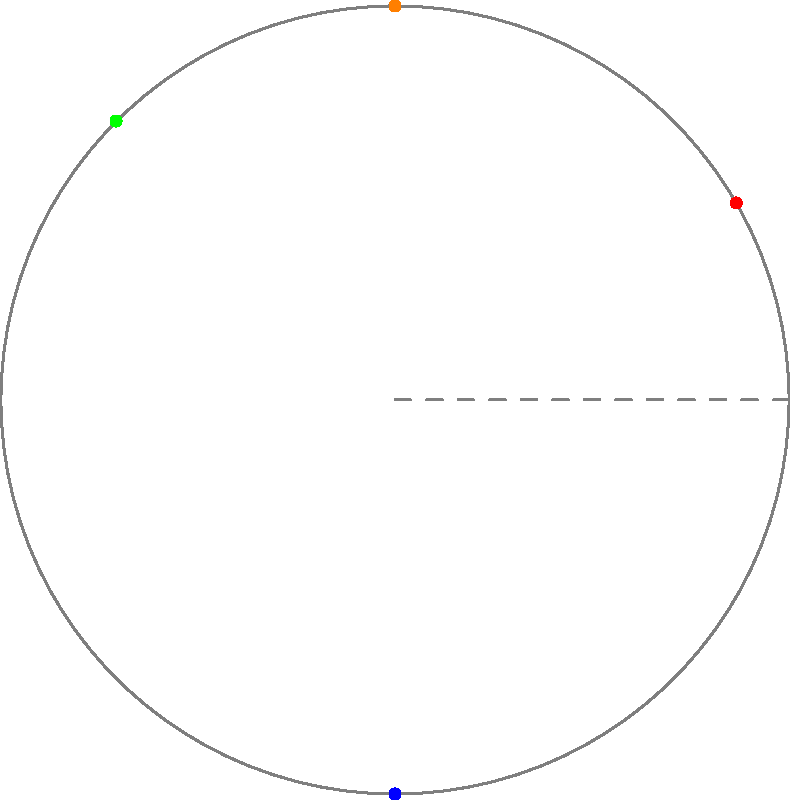As a young aspiring writer researching for your World War II novel, you've discovered that Allied forces used encrypted messages represented as points on a polar graph. Each point corresponds to a letter in the message. Given the following color-coded points on the polar graph:

Red (4.33, 2.5)
Blue (0, -5)
Green (-3.54, 3.54)
Orange (0, 5)

If the decryption key states that the message can be read by ordering the points from the smallest to the largest angle (measured counterclockwise from the positive x-axis), what is the correct order of the colored points? To solve this problem, we need to calculate the angle for each point in polar coordinates and then order them from smallest to largest. Let's go through this step-by-step:

1. Convert rectangular coordinates to polar coordinates:
   $r = \sqrt{x^2 + y^2}$, $\theta = \arctan(\frac{y}{x})$

2. Calculate the angle for each point:

   Red (4.33, 2.5):
   $\theta = \arctan(\frac{2.5}{4.33}) \approx 0.52$ radians or 30°

   Blue (0, -5):
   $\theta = \arctan(\frac{-5}{0}) = -\frac{\pi}{2}$ radians or -90°

   Green (-3.54, 3.54):
   $\theta = \arctan(\frac{3.54}{-3.54}) + \pi = \frac{3\pi}{4}$ radians or 135°

   Orange (0, 5):
   $\theta = \arctan(\frac{5}{0}) = \frac{\pi}{2}$ radians or 90°

3. Order the angles from smallest to largest:
   Blue (-90°) < Red (30°) < Orange (90°) < Green (135°)

Therefore, the correct order of the colored points from smallest to largest angle is: Blue, Red, Orange, Green.
Answer: Blue, Red, Orange, Green 